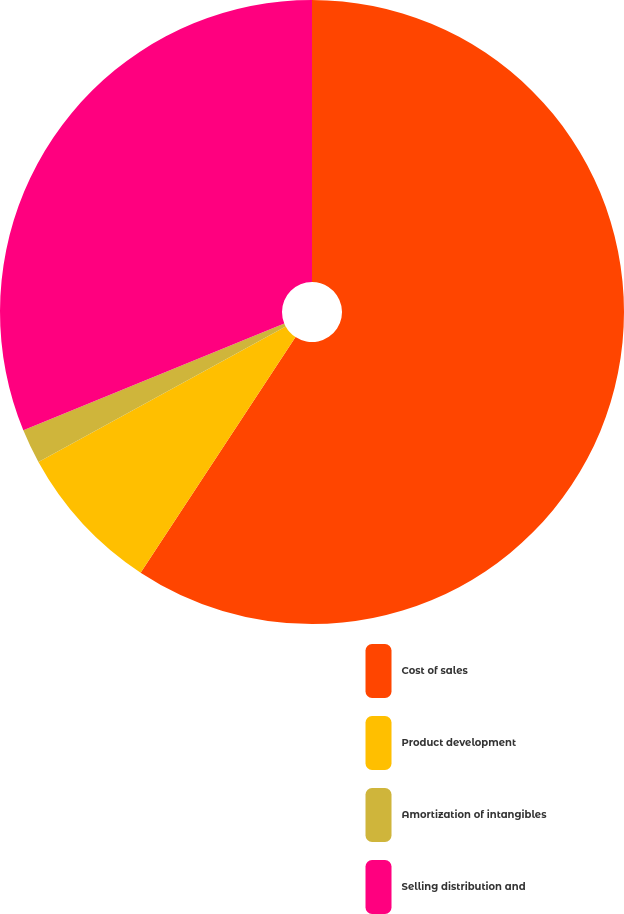<chart> <loc_0><loc_0><loc_500><loc_500><pie_chart><fcel>Cost of sales<fcel>Product development<fcel>Amortization of intangibles<fcel>Selling distribution and<nl><fcel>59.25%<fcel>7.76%<fcel>1.79%<fcel>31.19%<nl></chart> 